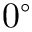<formula> <loc_0><loc_0><loc_500><loc_500>0 ^ { \circ }</formula> 